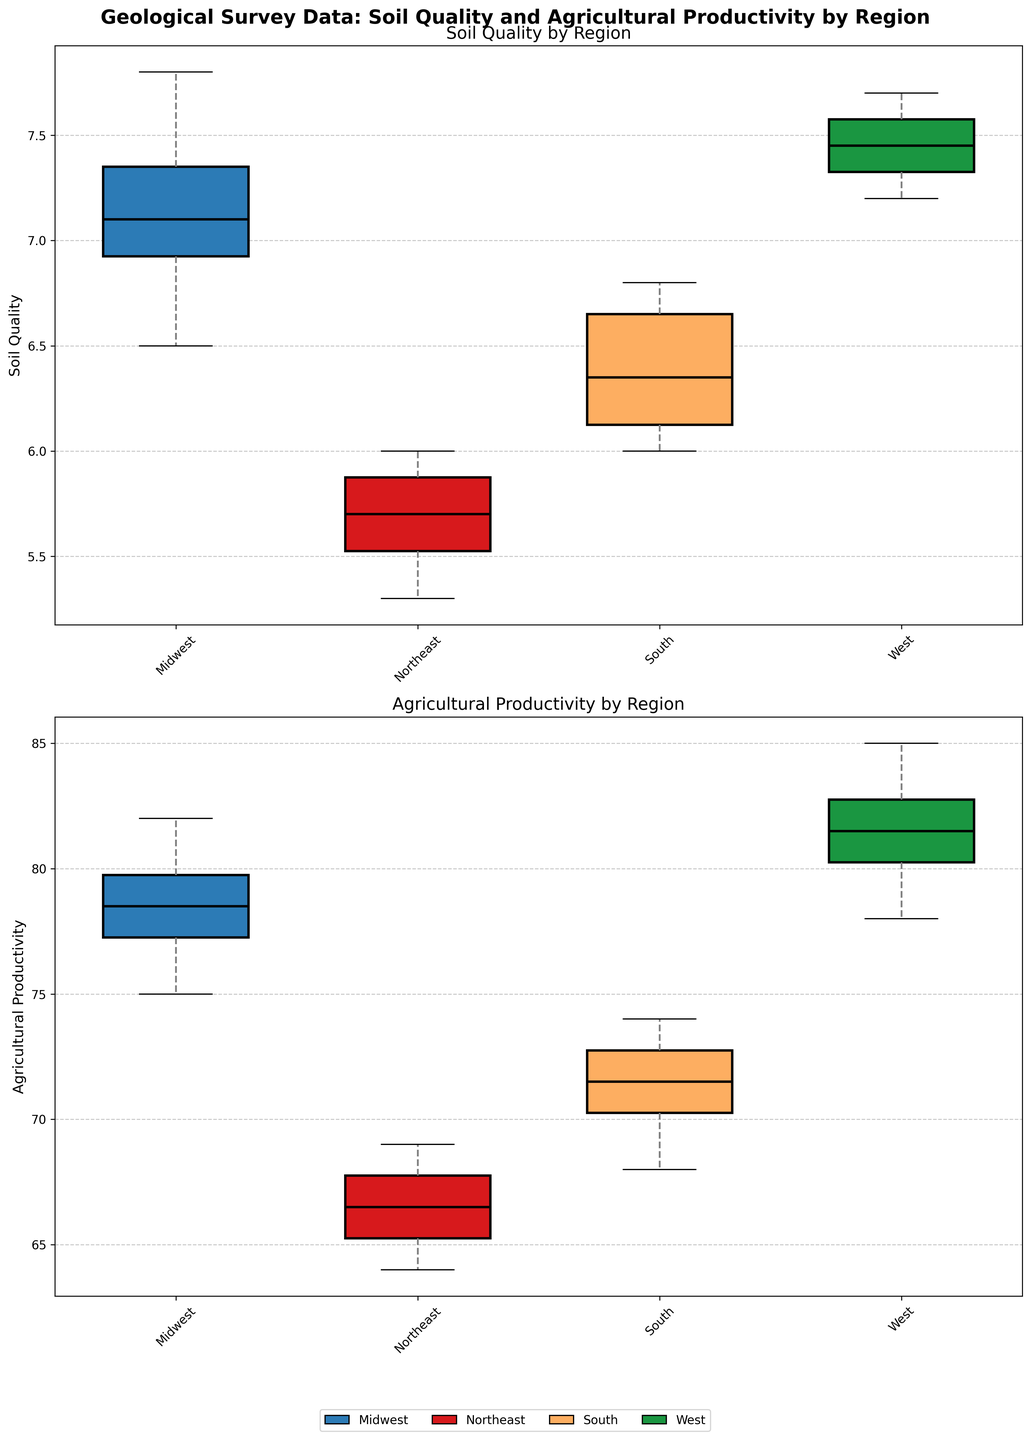Which region has the highest median soil quality? Look at the locations of the median lines within each box plot for soil quality. The West region has the highest median soil quality as its median line is the highest among the regions.
Answer: West How does the variability in agricultural productivity compare between the Midwest and the Northeast regions? Compare the lengths of the boxes and whiskers in the agricultural productivity plots for the Midwest and Northeast. The Northeast region has a wider range in its interquartile range (box length) and whiskers, indicating higher variability in agricultural productivity compared to Midwest.
Answer: Northeast has higher variability What is the relationship between soil quality and agricultural productivity for the West region? Observe both box plots for the West region. Both the median soil quality and agricultural productivity for the West region are high, indicating a positive relationship between soil quality and agricultural productivity.
Answer: Positive relationship Which region shows the greatest improvement in agricultural productivity compared to soil quality? Compare the differences between soil quality and agricultural productivity median lines for each region. The South region stands out with a median agricultural productivity much higher relative to its soil quality.
Answer: South Are there any outliers in the soil quality data for any of the regions? Look for points outside the whiskers in the soil quality box plots. The data indicates no outliers in the soil quality for any of the regions since no individual points are visible outside the whiskers.
Answer: No Which region has the lowest soil quality and agricultural productivity median values? Check the lowest points of the median lines in both box plots. The Northeast region has the lowest median values for both soil quality and agricultural productivity.
Answer: Northeast Is there any region where soil quality and agricultural productivity medians are almost equal? Compare the median lines in both box plots for all regions. The Midwest region shows almost equal median values for soil quality and agricultural productivity.
Answer: Midwest How does the interquartile range of soil quality in the South compare to that in the West? Check the lengths of the boxes (interquartile ranges) in the soil quality box plots for the South and West regions. The West has a slightly shorter interquartile range compared to the South, indicating lower variability.
Answer: South has higher interquartile range What can you infer about soil quality variability in the Northeast region based on the box plot? Observe the size of the box and the length of the whiskers in the soil quality box plot for the Northeast. The box and whiskers are quite narrow, indicating low variability in soil quality in the Northeast.
Answer: Low variability 